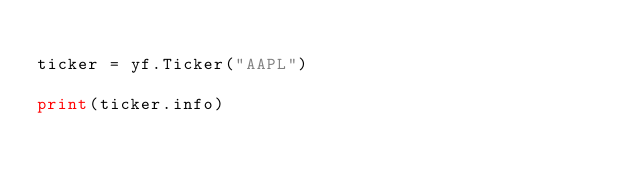Convert code to text. <code><loc_0><loc_0><loc_500><loc_500><_Python_>
ticker = yf.Ticker("AAPL")

print(ticker.info)</code> 